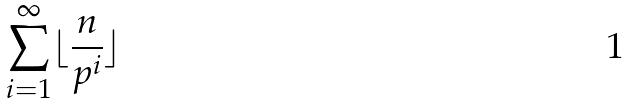<formula> <loc_0><loc_0><loc_500><loc_500>\sum _ { i = 1 } ^ { \infty } \lfloor \frac { n } { p ^ { i } } \rfloor</formula> 